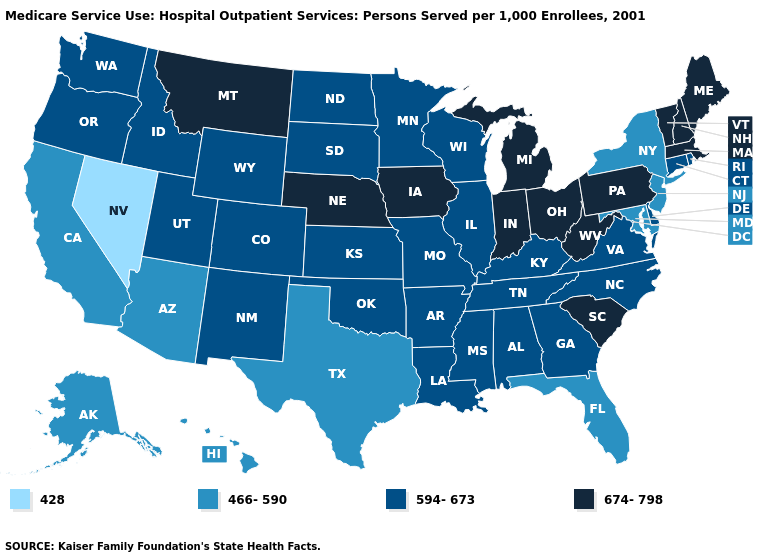Name the states that have a value in the range 594-673?
Concise answer only. Alabama, Arkansas, Colorado, Connecticut, Delaware, Georgia, Idaho, Illinois, Kansas, Kentucky, Louisiana, Minnesota, Mississippi, Missouri, New Mexico, North Carolina, North Dakota, Oklahoma, Oregon, Rhode Island, South Dakota, Tennessee, Utah, Virginia, Washington, Wisconsin, Wyoming. Does the map have missing data?
Be succinct. No. Does Texas have the highest value in the USA?
Concise answer only. No. Which states hav the highest value in the Northeast?
Answer briefly. Maine, Massachusetts, New Hampshire, Pennsylvania, Vermont. Does Massachusetts have the highest value in the USA?
Answer briefly. Yes. What is the value of New Hampshire?
Quick response, please. 674-798. Does the first symbol in the legend represent the smallest category?
Keep it brief. Yes. What is the value of Nebraska?
Write a very short answer. 674-798. Does Alabama have the lowest value in the USA?
Short answer required. No. Which states have the highest value in the USA?
Short answer required. Indiana, Iowa, Maine, Massachusetts, Michigan, Montana, Nebraska, New Hampshire, Ohio, Pennsylvania, South Carolina, Vermont, West Virginia. Among the states that border Massachusetts , which have the lowest value?
Be succinct. New York. Among the states that border Rhode Island , which have the lowest value?
Keep it brief. Connecticut. What is the highest value in the USA?
Write a very short answer. 674-798. What is the value of Louisiana?
Be succinct. 594-673. 